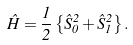<formula> <loc_0><loc_0><loc_500><loc_500>\hat { H } = \frac { 1 } { 2 } \left \{ \hat { S } _ { 0 } ^ { 2 } + \hat { S } _ { 1 } ^ { 2 } \right \} .</formula> 